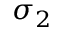<formula> <loc_0><loc_0><loc_500><loc_500>\sigma _ { 2 }</formula> 